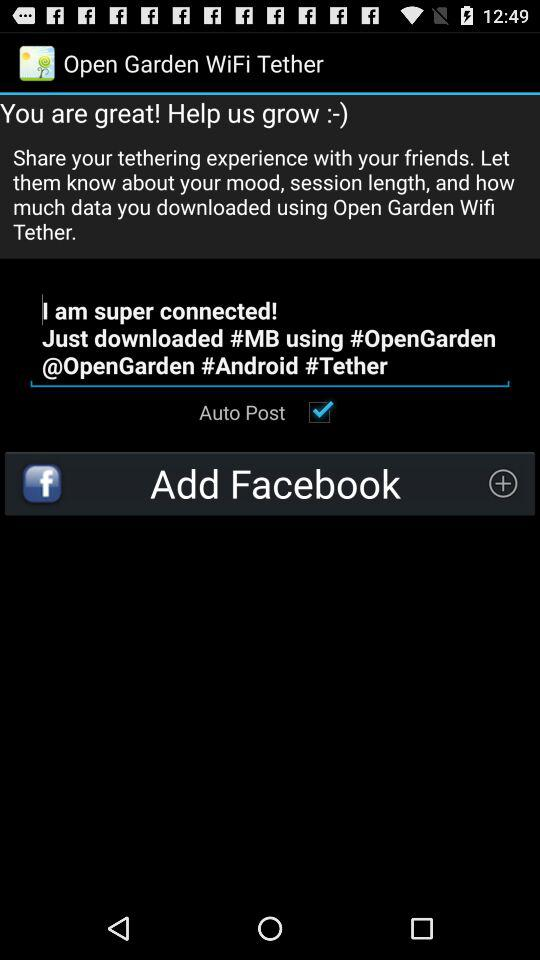What do we need to add? You need to add "Facebook". 